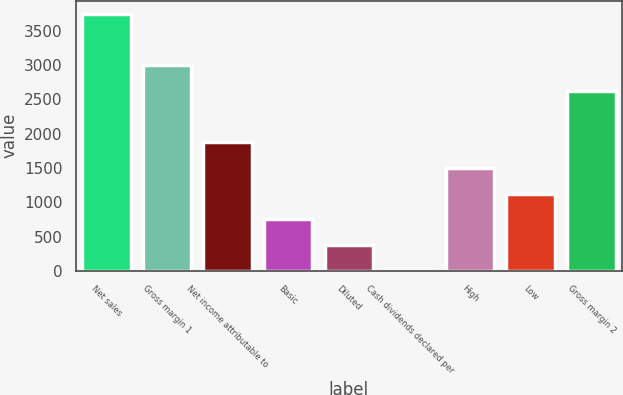<chart> <loc_0><loc_0><loc_500><loc_500><bar_chart><fcel>Net sales<fcel>Gross margin 1<fcel>Net income attributable to<fcel>Basic<fcel>Diluted<fcel>Cash dividends declared per<fcel>High<fcel>Low<fcel>Gross margin 2<nl><fcel>3753<fcel>3002.53<fcel>1876.75<fcel>750.97<fcel>375.71<fcel>0.45<fcel>1501.49<fcel>1126.23<fcel>2627.27<nl></chart> 